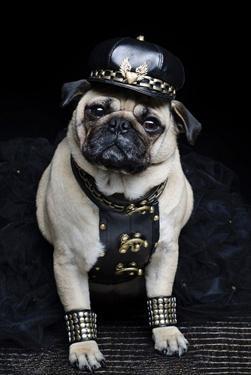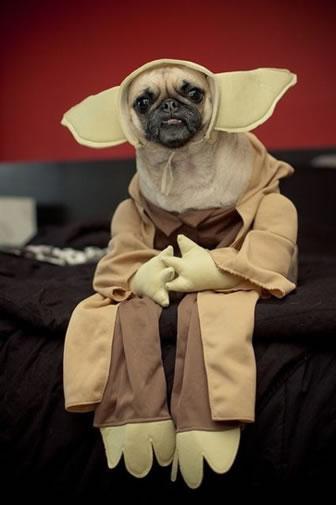The first image is the image on the left, the second image is the image on the right. Examine the images to the left and right. Is the description "One of the dogs shown is wearing a hat with a brim." accurate? Answer yes or no. Yes. 